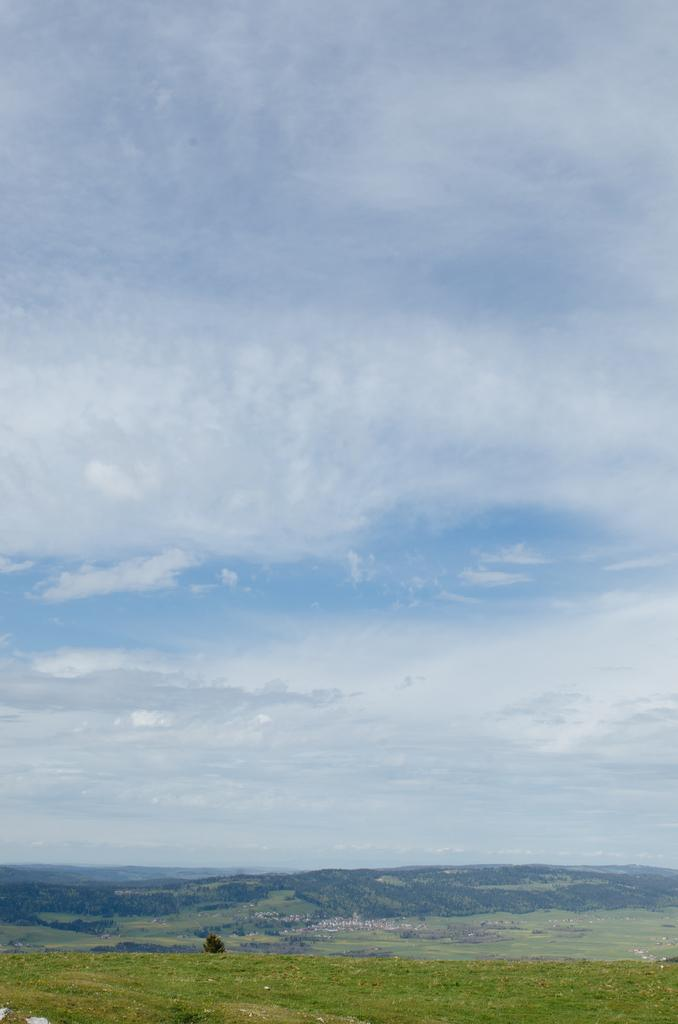What type of natural formation can be seen in the image? There are mountains in the image. What is located in the foreground of the image? There is a tree in the foreground of the image. What is visible at the top of the image? The sky is visible at the top of the image. What can be seen in the sky? There are clouds in the sky. What type of vegetation is present at the bottom of the image? Grass is present at the bottom of the image. What type of egg is depicted in the middle of the image? There is no egg present in the image; it features mountains, a tree, the sky, clouds, and grass. What is the title of the image? The image does not have a title, as it is a photograph or illustration and not a piece of literature or artwork with a specific title. 